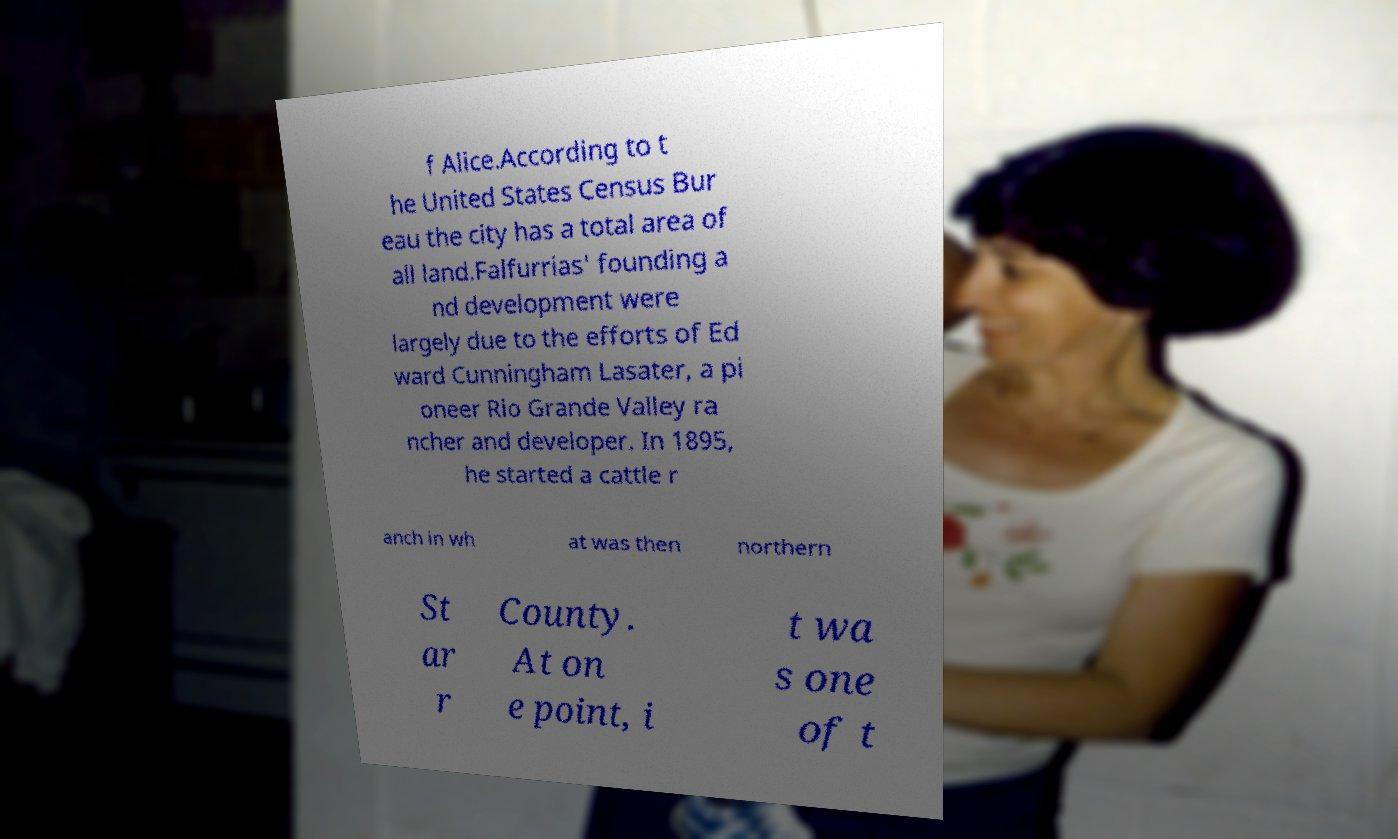Can you read and provide the text displayed in the image?This photo seems to have some interesting text. Can you extract and type it out for me? f Alice.According to t he United States Census Bur eau the city has a total area of all land.Falfurrias' founding a nd development were largely due to the efforts of Ed ward Cunningham Lasater, a pi oneer Rio Grande Valley ra ncher and developer. In 1895, he started a cattle r anch in wh at was then northern St ar r County. At on e point, i t wa s one of t 